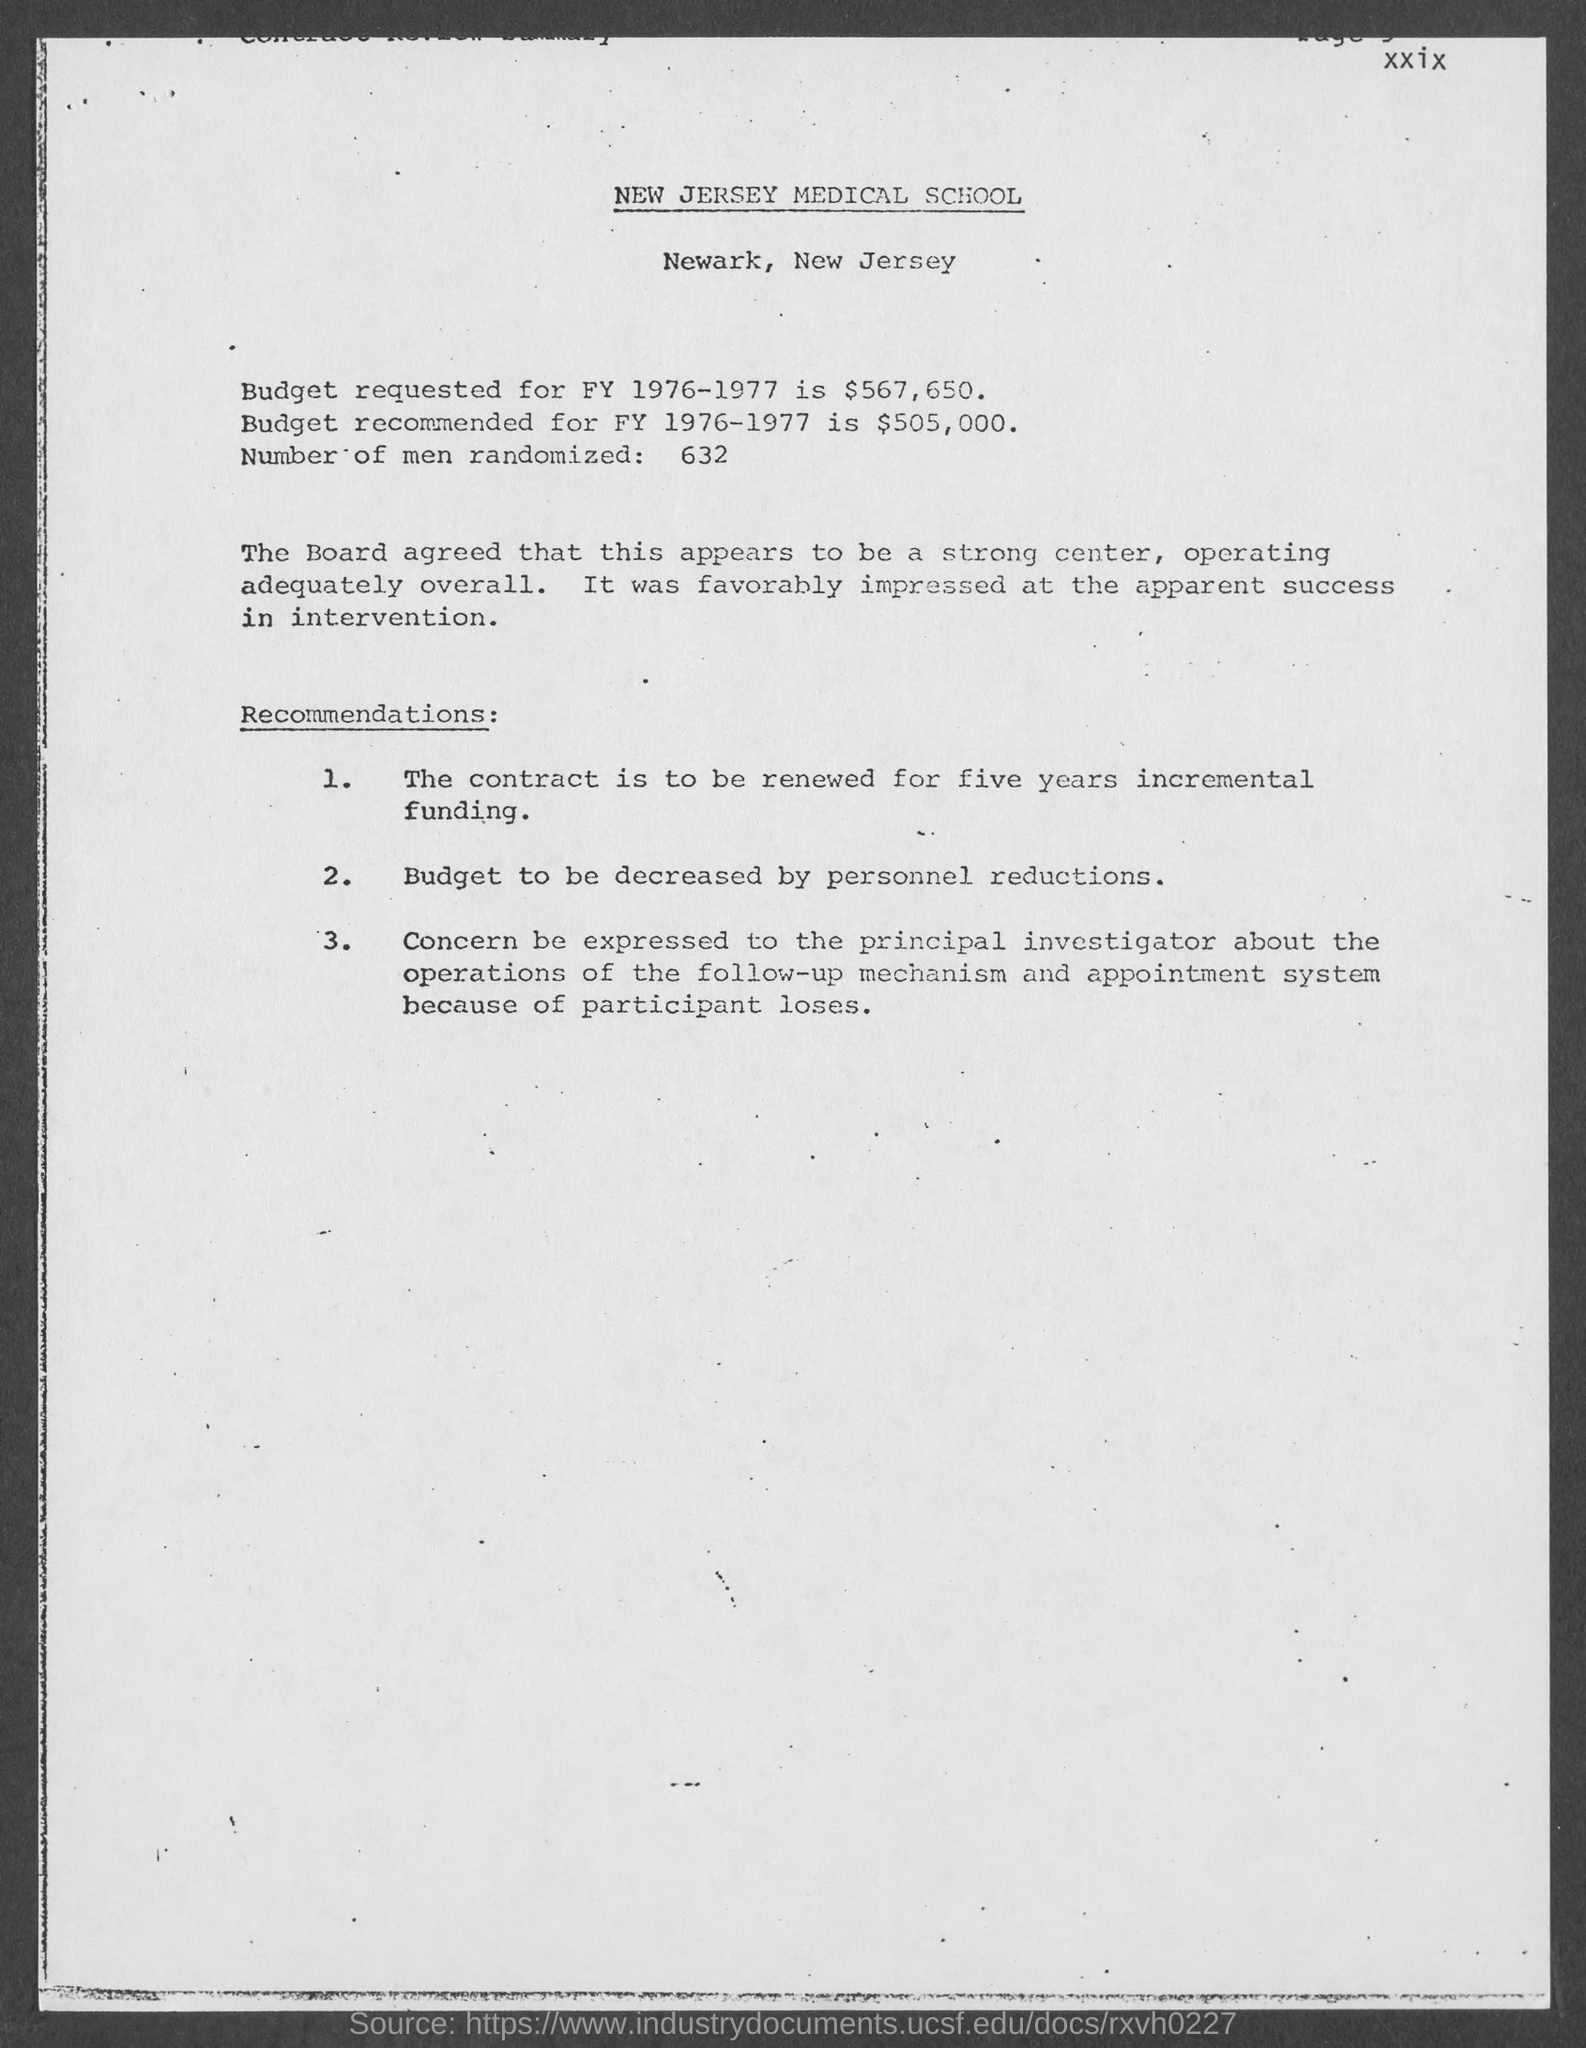Can you elaborate on why the budget was recommended to be lower than requested? The document suggests that the budget recommended for FY 1976-1977 was set at $505,000, lower than the requested $567,650, possibly due to constraints in funding or assessments of what was necessary to achieve the project's goals effectively. 